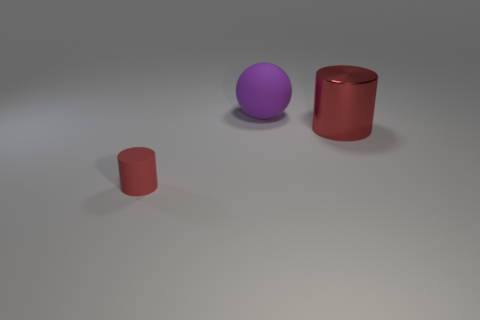How many things are things behind the red metal cylinder or gray rubber balls?
Keep it short and to the point. 1. What is the size of the cylinder to the right of the rubber object in front of the red object that is to the right of the tiny object?
Your answer should be very brief. Large. There is another cylinder that is the same color as the tiny cylinder; what is it made of?
Make the answer very short. Metal. Is there any other thing that is the same shape as the red rubber object?
Offer a very short reply. Yes. There is a rubber thing that is behind the cylinder to the left of the large sphere; how big is it?
Offer a terse response. Large. How many big objects are either things or red shiny objects?
Your answer should be compact. 2. Are there fewer yellow rubber cylinders than large red objects?
Provide a short and direct response. Yes. Are there any other things that have the same size as the purple ball?
Provide a succinct answer. Yes. Do the tiny rubber cylinder and the large metal thing have the same color?
Your response must be concise. Yes. Are there more large purple rubber things than rubber things?
Offer a very short reply. No. 